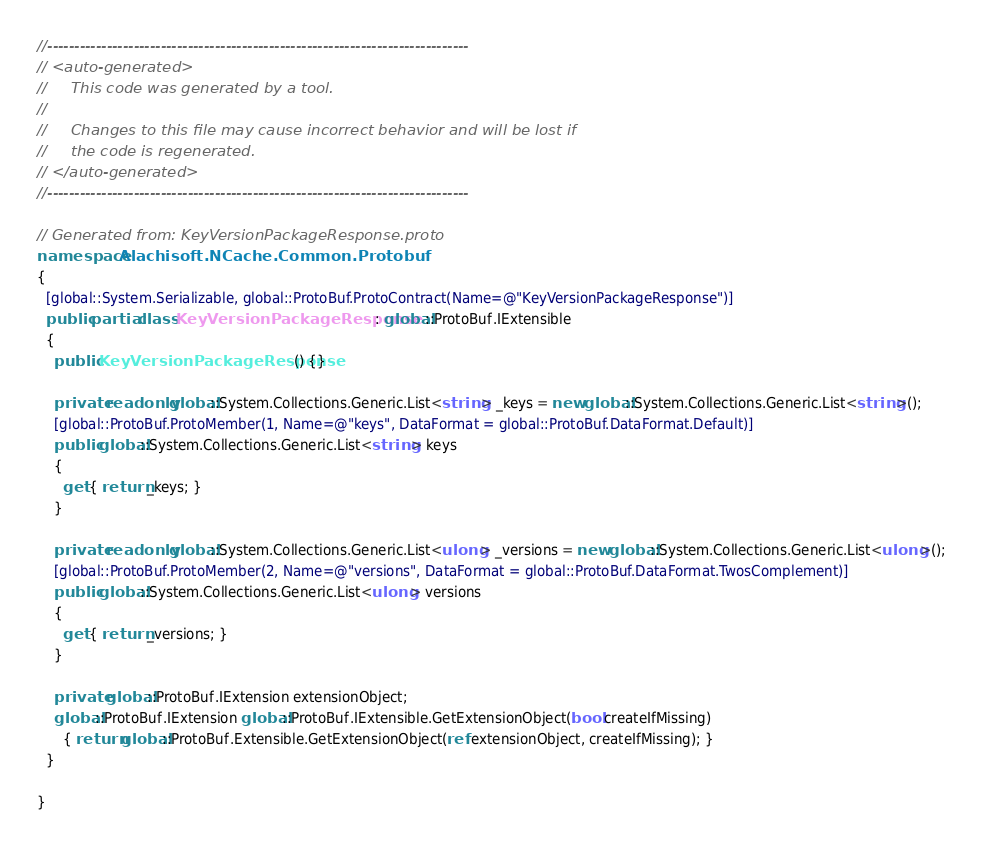<code> <loc_0><loc_0><loc_500><loc_500><_C#_>//------------------------------------------------------------------------------
// <auto-generated>
//     This code was generated by a tool.
//
//     Changes to this file may cause incorrect behavior and will be lost if
//     the code is regenerated.
// </auto-generated>
//------------------------------------------------------------------------------

// Generated from: KeyVersionPackageResponse.proto
namespace Alachisoft.NCache.Common.Protobuf
{
  [global::System.Serializable, global::ProtoBuf.ProtoContract(Name=@"KeyVersionPackageResponse")]
  public partial class KeyVersionPackageResponse : global::ProtoBuf.IExtensible
  {
    public KeyVersionPackageResponse() {}
    
    private readonly global::System.Collections.Generic.List<string> _keys = new global::System.Collections.Generic.List<string>();
    [global::ProtoBuf.ProtoMember(1, Name=@"keys", DataFormat = global::ProtoBuf.DataFormat.Default)]
    public global::System.Collections.Generic.List<string> keys
    {
      get { return _keys; }
    }
  
    private readonly global::System.Collections.Generic.List<ulong> _versions = new global::System.Collections.Generic.List<ulong>();
    [global::ProtoBuf.ProtoMember(2, Name=@"versions", DataFormat = global::ProtoBuf.DataFormat.TwosComplement)]
    public global::System.Collections.Generic.List<ulong> versions
    {
      get { return _versions; }
    }
  
    private global::ProtoBuf.IExtension extensionObject;
    global::ProtoBuf.IExtension global::ProtoBuf.IExtensible.GetExtensionObject(bool createIfMissing)
      { return global::ProtoBuf.Extensible.GetExtensionObject(ref extensionObject, createIfMissing); }
  }
  
}</code> 